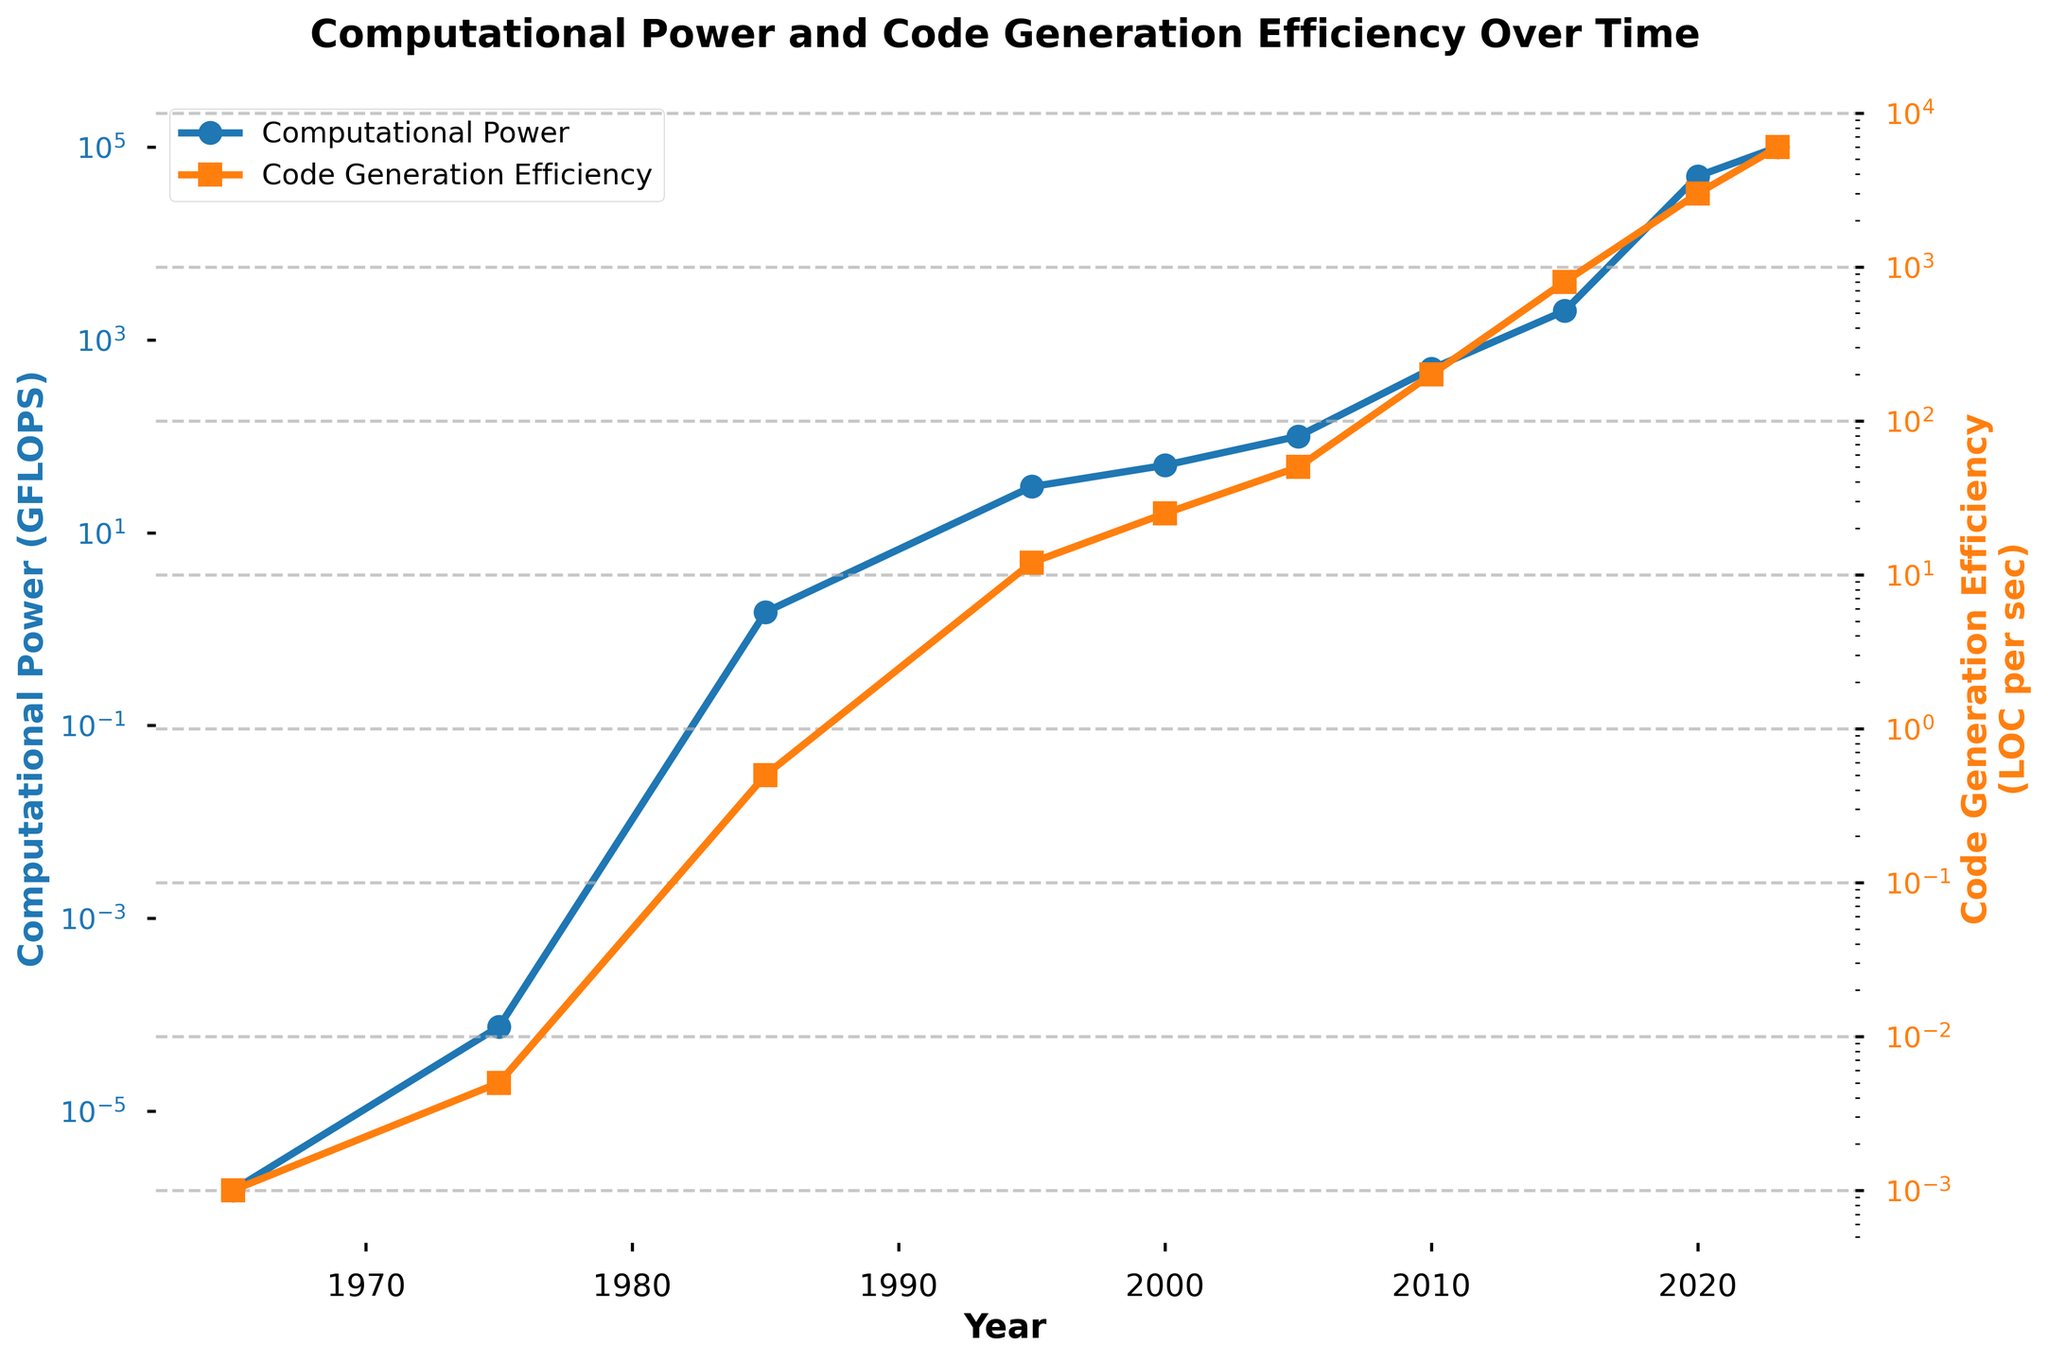what is the title of the plot? The title is the text that appears at the top of the plot, summarizing what the plot is about. It reads "Computational Power and Code Generation Efficiency Over Time".
Answer: "Computational Power and Code Generation Efficiency Over Time" What color is used for the computational power line? The color of the computational power line can be identified by looking at the plot. It is represented in blue.
Answer: Blue How many data points are there for the code generation efficiency? By counting the number of markers (squares) along the code generation efficiency line, you can determine the number of data points. There are 10 points.
Answer: 10 What was the computational power in 1985? Locate the year 1985 on the x-axis and follow the line for computational power. The corresponding computational power value is 1.5 GFLOPS.
Answer: 1.5 GFLOPS What's the average code generation efficiency from 2000 to 2010? The code generation efficiecy in 2000 (25), 2005 (50), and 2010 (200) and sum up to get 275. Dividing 275 by 3 yields the average.
Answer: 91.67 LOC per sec In which year does the computational power first exceed 1000 GFLOPS? Follow the computational power line and identify the year where it crosses 1000 GFLOPS, which occurs in 2015.
Answer: 2015 Which data series shows a higher increase in value between 2010 and 2020? By comparing the computational power (500 to 50000 GFLOPS) and code generation efficiency (200 to 3000 LOC per sec) between 2010 and 2020, the computational power increase is 49500 GFLOPS while the efficiency increases by 2800 LOC per sec. Hence, computational power has a higher increase.
Answer: Computational Power What is the difference in code generation efficiency between the years 2005 and 2023? Subtract the 2005 efficiency value (50) from the 2023 efficiency value (6000). The difference is 5950.
Answer: 5950 LOC per sec 